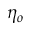<formula> <loc_0><loc_0><loc_500><loc_500>\eta _ { o }</formula> 